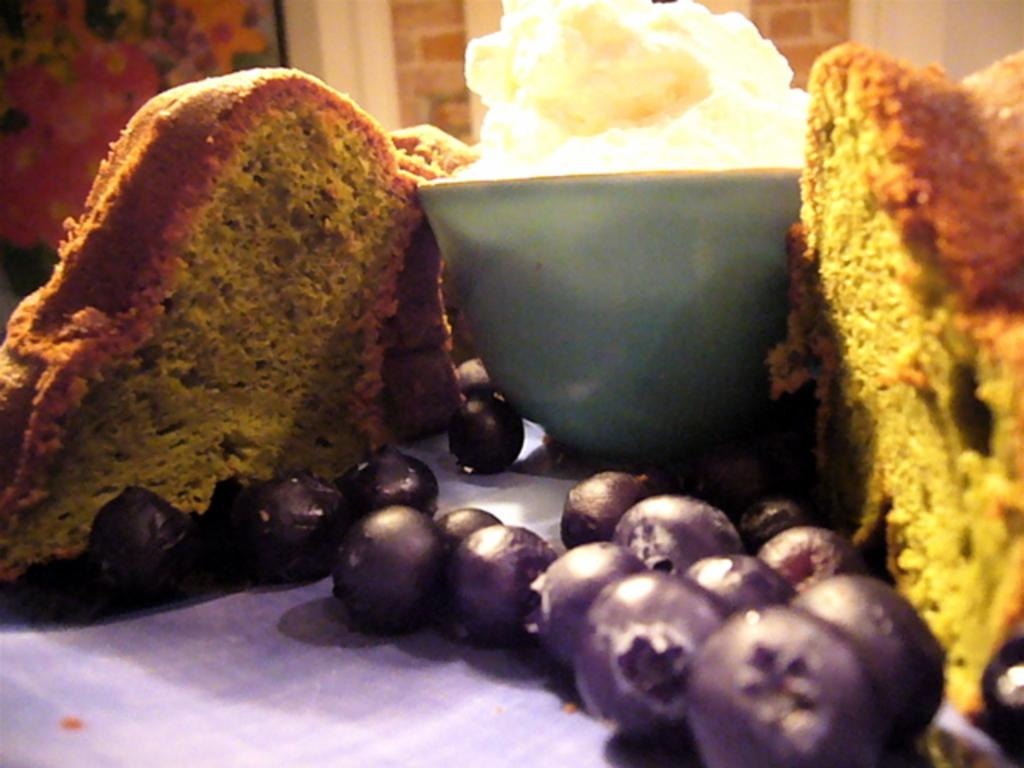What type of dessert can be seen in the image? There are two pieces of cake in the image. What fruit is present in the image? There are blueberries in the image. What is the container in the image used for? The cup is filled with a food item. What color is the cloth in the image? The cloth is lavender in color. What songs are being sung by the cake in the image? There are no songs being sung by the cake in the image, as cakes do not have the ability to sing. 